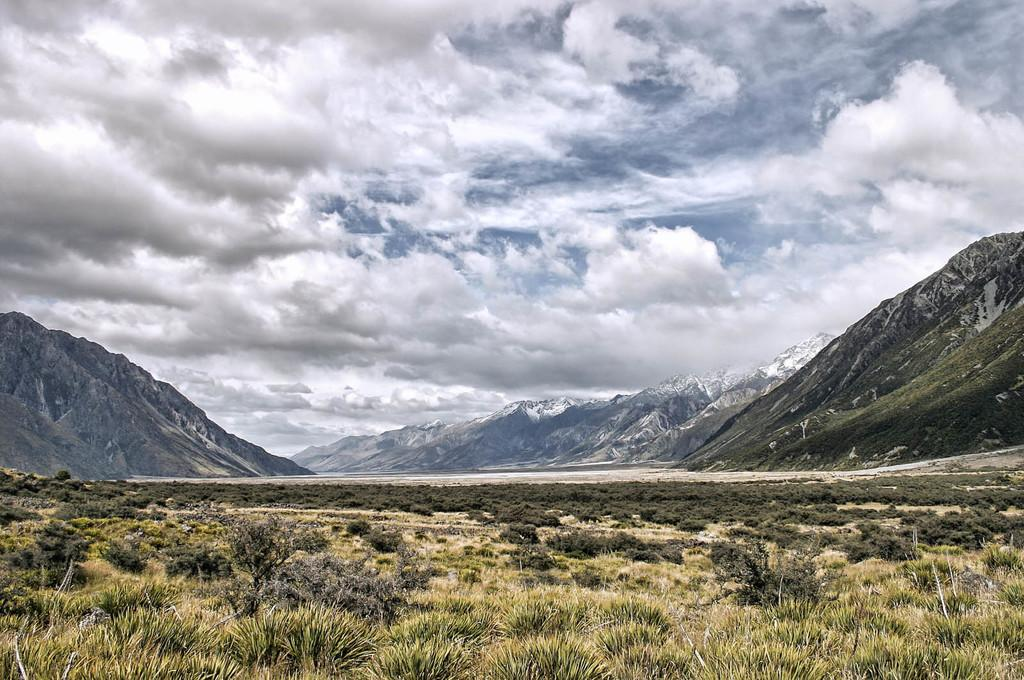What type of vegetation is at the bottom of the image? There is grass and plants at the bottom of the image. What type of natural features can be seen in the background of the image? There are mountains in the background of the image. What is visible at the top of the image? The sky is visible at the top of the image. What can be observed in the sky? Clouds are present in the sky. What type of eggs can be seen in the image? There are no eggs present in the image. What industry is depicted in the image? There is no industry depicted in the image; it features grass, plants, mountains, and clouds. 